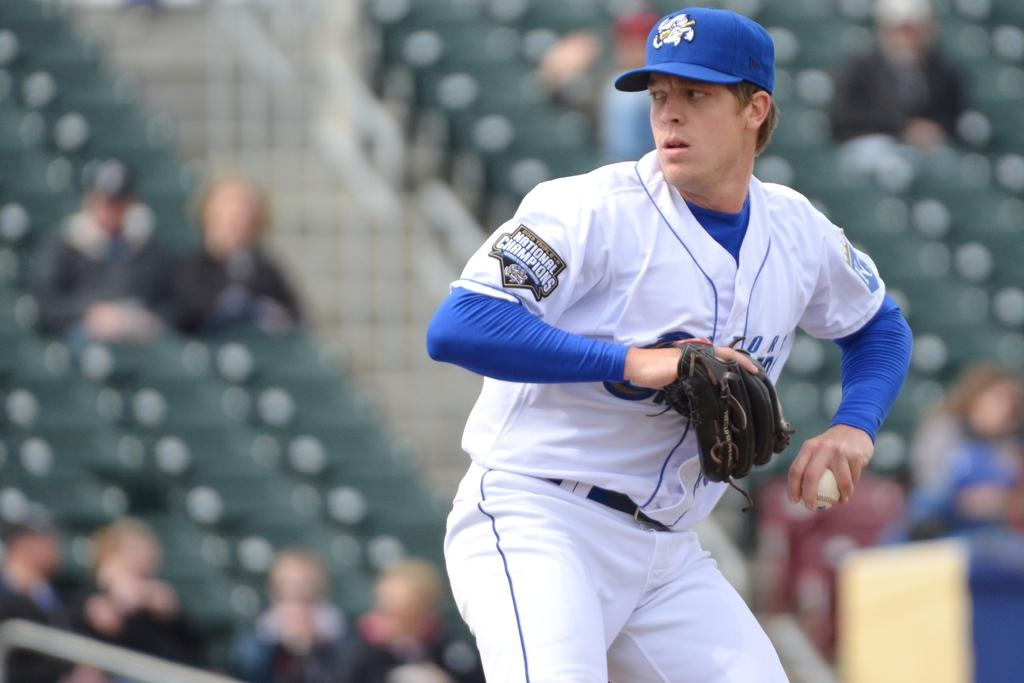Provide a one-sentence caption for the provided image. The baseball player about to throw the ball is from a team that is the national champions. 